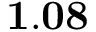Convert formula to latex. <formula><loc_0><loc_0><loc_500><loc_500>1 . 0 8</formula> 